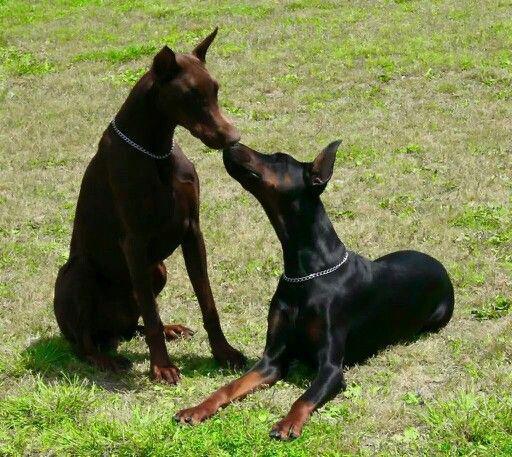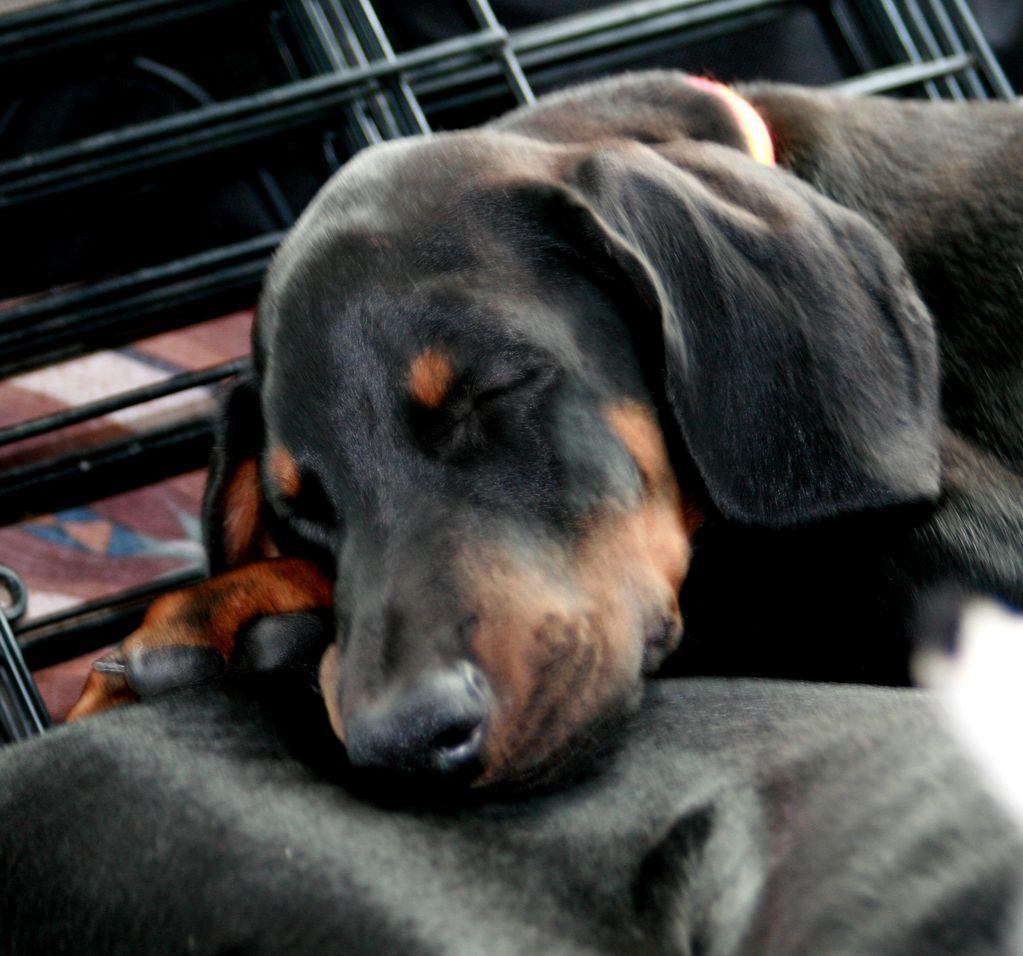The first image is the image on the left, the second image is the image on the right. Considering the images on both sides, is "there are two dogs on the grass, one of the dogs is laying down" valid? Answer yes or no. Yes. The first image is the image on the left, the second image is the image on the right. Evaluate the accuracy of this statement regarding the images: "There are three dogs and one is a puppy.". Is it true? Answer yes or no. Yes. 